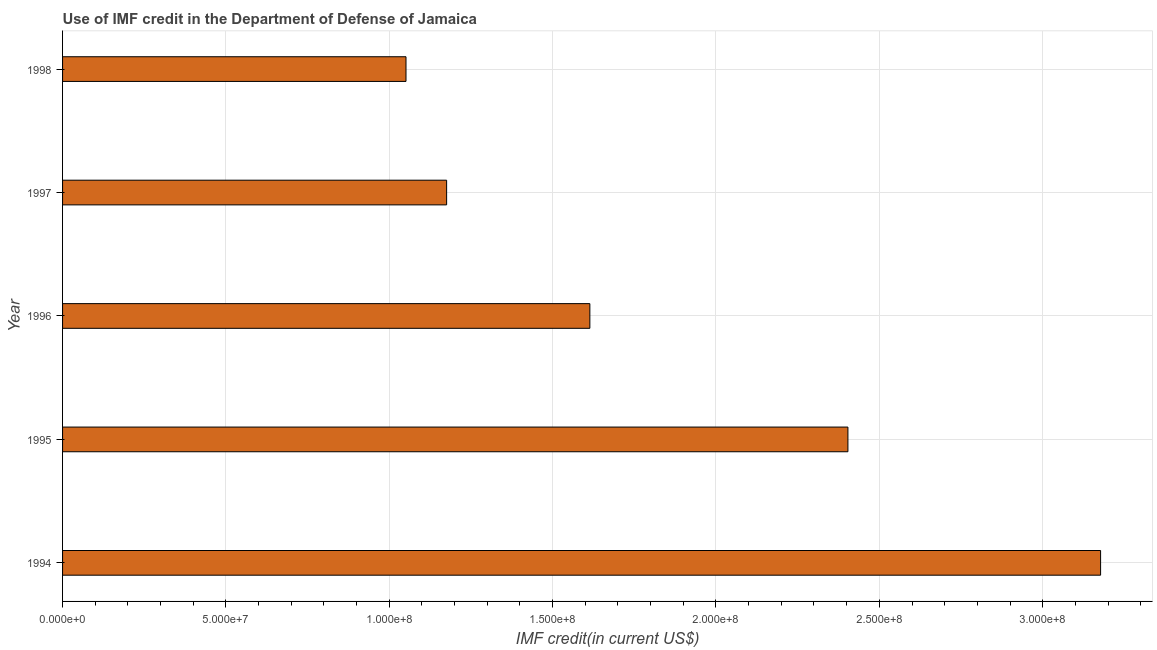Does the graph contain any zero values?
Make the answer very short. No. Does the graph contain grids?
Your answer should be very brief. Yes. What is the title of the graph?
Provide a short and direct response. Use of IMF credit in the Department of Defense of Jamaica. What is the label or title of the X-axis?
Your response must be concise. IMF credit(in current US$). What is the label or title of the Y-axis?
Provide a succinct answer. Year. What is the use of imf credit in dod in 1998?
Provide a short and direct response. 1.05e+08. Across all years, what is the maximum use of imf credit in dod?
Keep it short and to the point. 3.18e+08. Across all years, what is the minimum use of imf credit in dod?
Your response must be concise. 1.05e+08. In which year was the use of imf credit in dod minimum?
Your answer should be compact. 1998. What is the sum of the use of imf credit in dod?
Offer a terse response. 9.42e+08. What is the difference between the use of imf credit in dod in 1994 and 1997?
Provide a succinct answer. 2.00e+08. What is the average use of imf credit in dod per year?
Ensure brevity in your answer.  1.88e+08. What is the median use of imf credit in dod?
Offer a very short reply. 1.61e+08. Do a majority of the years between 1995 and 1997 (inclusive) have use of imf credit in dod greater than 20000000 US$?
Your response must be concise. Yes. What is the ratio of the use of imf credit in dod in 1994 to that in 1997?
Ensure brevity in your answer.  2.7. Is the use of imf credit in dod in 1994 less than that in 1995?
Provide a succinct answer. No. What is the difference between the highest and the second highest use of imf credit in dod?
Your answer should be very brief. 7.73e+07. What is the difference between the highest and the lowest use of imf credit in dod?
Give a very brief answer. 2.13e+08. In how many years, is the use of imf credit in dod greater than the average use of imf credit in dod taken over all years?
Offer a terse response. 2. How many bars are there?
Your answer should be compact. 5. How many years are there in the graph?
Your answer should be very brief. 5. What is the difference between two consecutive major ticks on the X-axis?
Offer a very short reply. 5.00e+07. What is the IMF credit(in current US$) in 1994?
Offer a very short reply. 3.18e+08. What is the IMF credit(in current US$) of 1995?
Your response must be concise. 2.40e+08. What is the IMF credit(in current US$) in 1996?
Ensure brevity in your answer.  1.61e+08. What is the IMF credit(in current US$) of 1997?
Your answer should be very brief. 1.18e+08. What is the IMF credit(in current US$) in 1998?
Keep it short and to the point. 1.05e+08. What is the difference between the IMF credit(in current US$) in 1994 and 1995?
Your answer should be compact. 7.73e+07. What is the difference between the IMF credit(in current US$) in 1994 and 1996?
Offer a very short reply. 1.56e+08. What is the difference between the IMF credit(in current US$) in 1994 and 1997?
Your response must be concise. 2.00e+08. What is the difference between the IMF credit(in current US$) in 1994 and 1998?
Your response must be concise. 2.13e+08. What is the difference between the IMF credit(in current US$) in 1995 and 1996?
Offer a very short reply. 7.90e+07. What is the difference between the IMF credit(in current US$) in 1995 and 1997?
Make the answer very short. 1.23e+08. What is the difference between the IMF credit(in current US$) in 1995 and 1998?
Provide a short and direct response. 1.35e+08. What is the difference between the IMF credit(in current US$) in 1996 and 1997?
Offer a very short reply. 4.38e+07. What is the difference between the IMF credit(in current US$) in 1996 and 1998?
Your answer should be compact. 5.63e+07. What is the difference between the IMF credit(in current US$) in 1997 and 1998?
Offer a terse response. 1.24e+07. What is the ratio of the IMF credit(in current US$) in 1994 to that in 1995?
Keep it short and to the point. 1.32. What is the ratio of the IMF credit(in current US$) in 1994 to that in 1996?
Ensure brevity in your answer.  1.97. What is the ratio of the IMF credit(in current US$) in 1994 to that in 1997?
Offer a very short reply. 2.7. What is the ratio of the IMF credit(in current US$) in 1994 to that in 1998?
Provide a short and direct response. 3.02. What is the ratio of the IMF credit(in current US$) in 1995 to that in 1996?
Your answer should be compact. 1.49. What is the ratio of the IMF credit(in current US$) in 1995 to that in 1997?
Your answer should be very brief. 2.04. What is the ratio of the IMF credit(in current US$) in 1995 to that in 1998?
Provide a short and direct response. 2.29. What is the ratio of the IMF credit(in current US$) in 1996 to that in 1997?
Your response must be concise. 1.37. What is the ratio of the IMF credit(in current US$) in 1996 to that in 1998?
Offer a terse response. 1.53. What is the ratio of the IMF credit(in current US$) in 1997 to that in 1998?
Give a very brief answer. 1.12. 